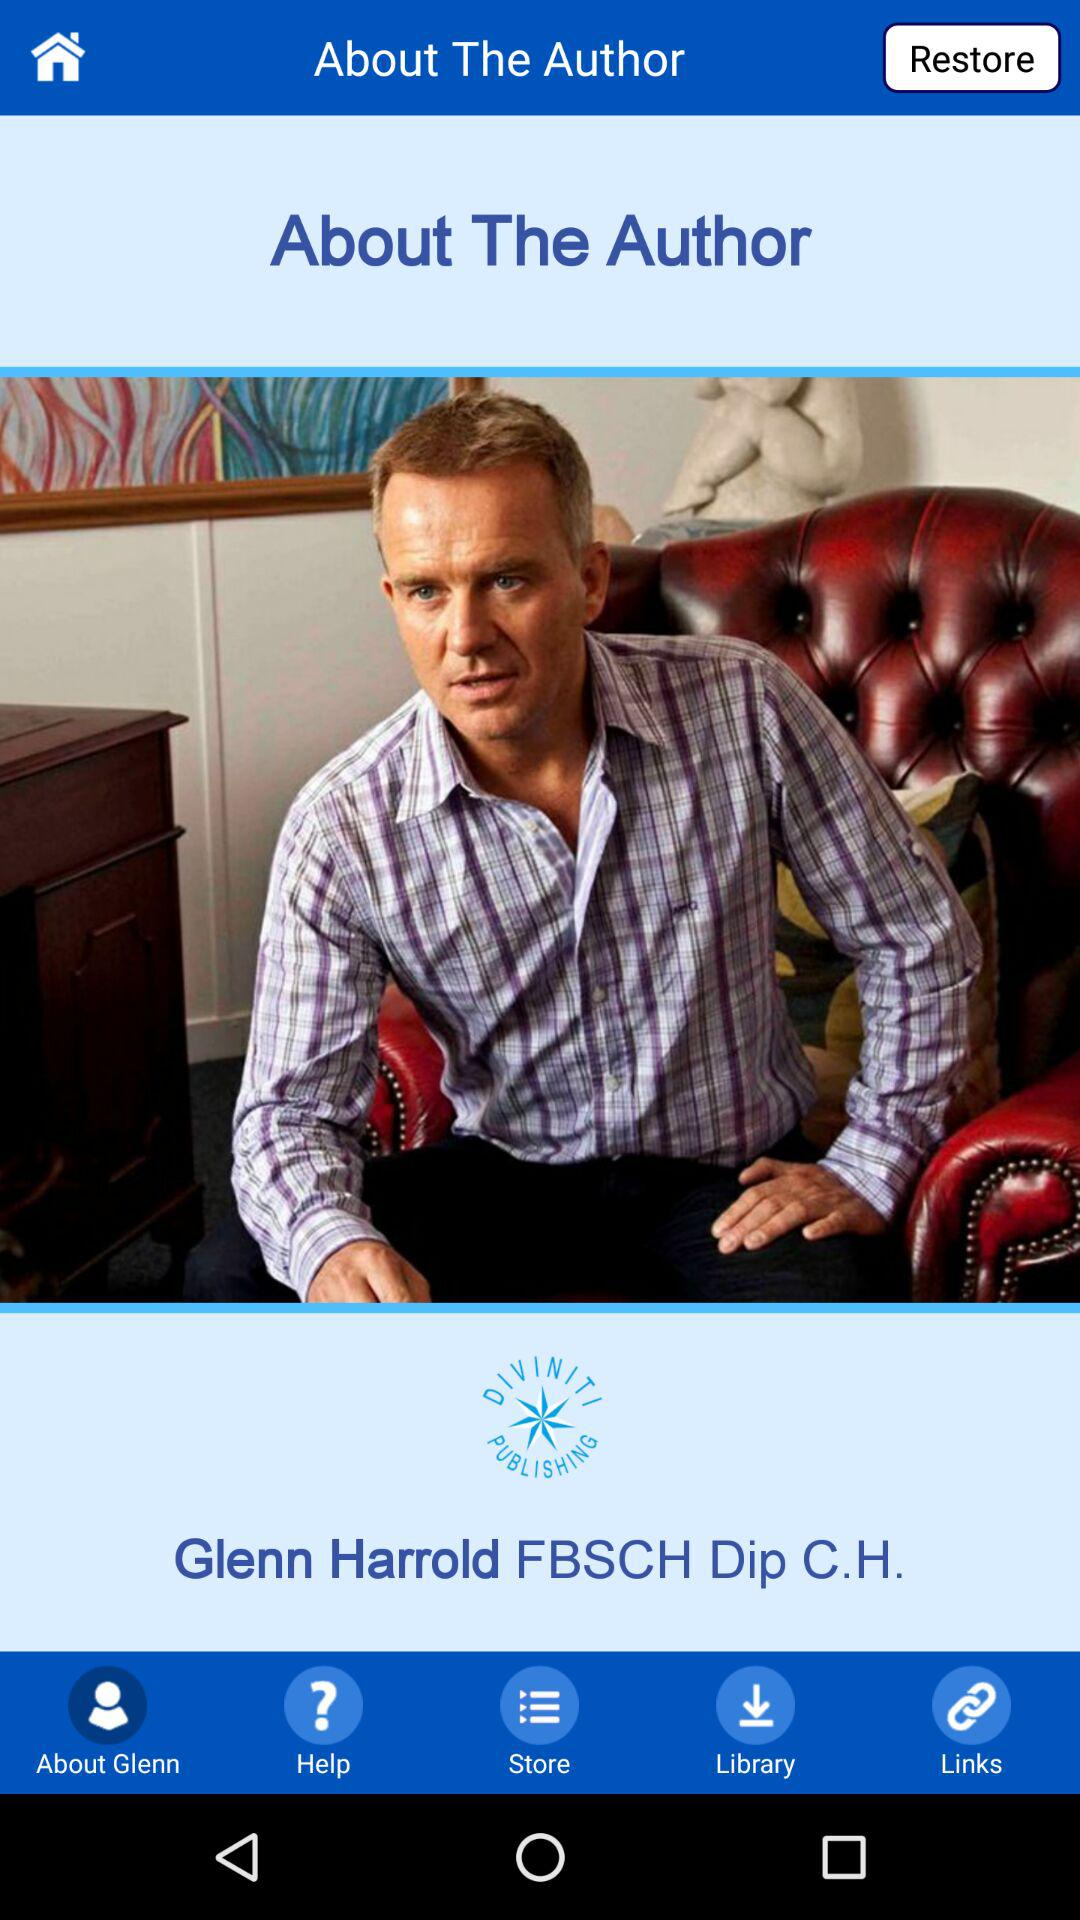What is the name of the author? The name of the author is Glenn Harrold. 